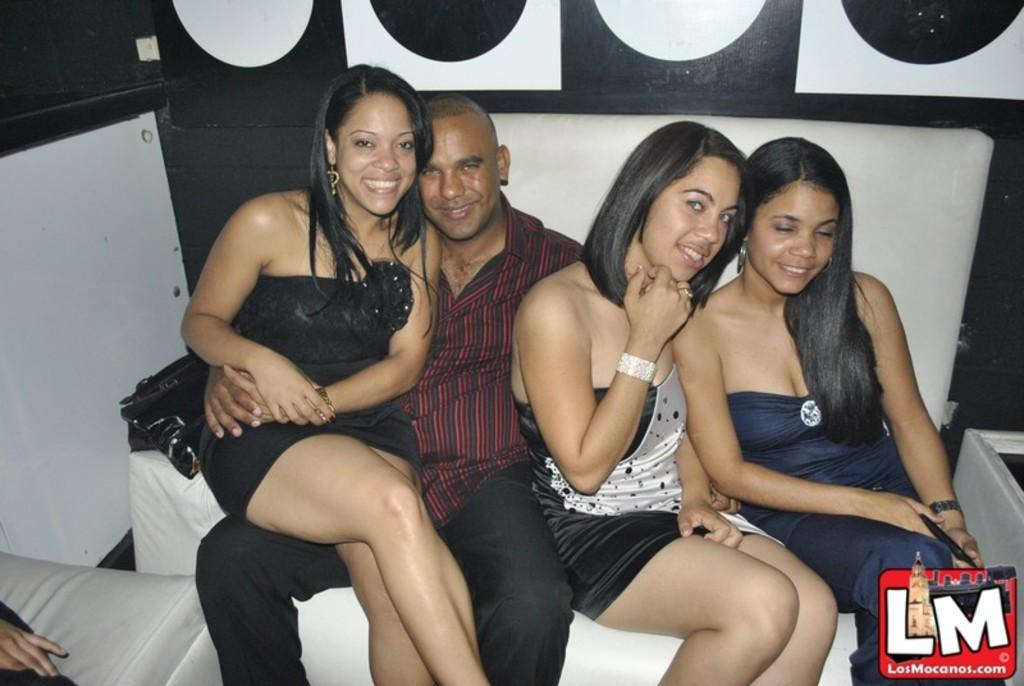How many individuals are present in the image? There are four people in the image. Can you describe the gender of the people in the image? One of the people is a man, and three of the people are women. What are the people in the image doing? All the people are posing for the photo. What is visible behind the people in the image? There is a wall behind the people. What shape is the cent taking in the image? There is no cent present in the image, and therefore no shape can be attributed to it. 